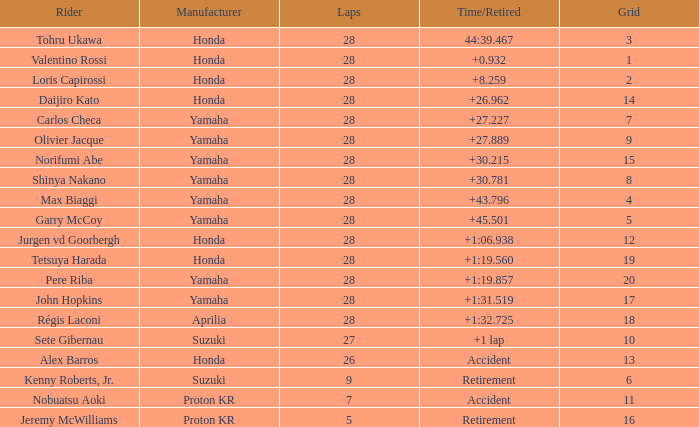Parse the full table. {'header': ['Rider', 'Manufacturer', 'Laps', 'Time/Retired', 'Grid'], 'rows': [['Tohru Ukawa', 'Honda', '28', '44:39.467', '3'], ['Valentino Rossi', 'Honda', '28', '+0.932', '1'], ['Loris Capirossi', 'Honda', '28', '+8.259', '2'], ['Daijiro Kato', 'Honda', '28', '+26.962', '14'], ['Carlos Checa', 'Yamaha', '28', '+27.227', '7'], ['Olivier Jacque', 'Yamaha', '28', '+27.889', '9'], ['Norifumi Abe', 'Yamaha', '28', '+30.215', '15'], ['Shinya Nakano', 'Yamaha', '28', '+30.781', '8'], ['Max Biaggi', 'Yamaha', '28', '+43.796', '4'], ['Garry McCoy', 'Yamaha', '28', '+45.501', '5'], ['Jurgen vd Goorbergh', 'Honda', '28', '+1:06.938', '12'], ['Tetsuya Harada', 'Honda', '28', '+1:19.560', '19'], ['Pere Riba', 'Yamaha', '28', '+1:19.857', '20'], ['John Hopkins', 'Yamaha', '28', '+1:31.519', '17'], ['Régis Laconi', 'Aprilia', '28', '+1:32.725', '18'], ['Sete Gibernau', 'Suzuki', '27', '+1 lap', '10'], ['Alex Barros', 'Honda', '26', 'Accident', '13'], ['Kenny Roberts, Jr.', 'Suzuki', '9', 'Retirement', '6'], ['Nobuatsu Aoki', 'Proton KR', '7', 'Accident', '11'], ['Jeremy McWilliams', 'Proton KR', '5', 'Retirement', '16']]} How many laps did pere riba ride? 28.0. 